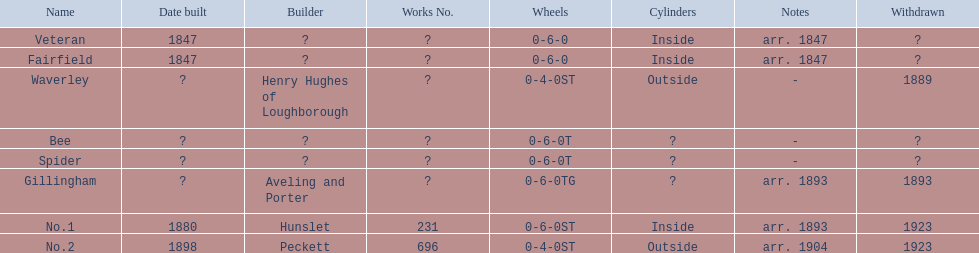How many were built in 1847? 2. 